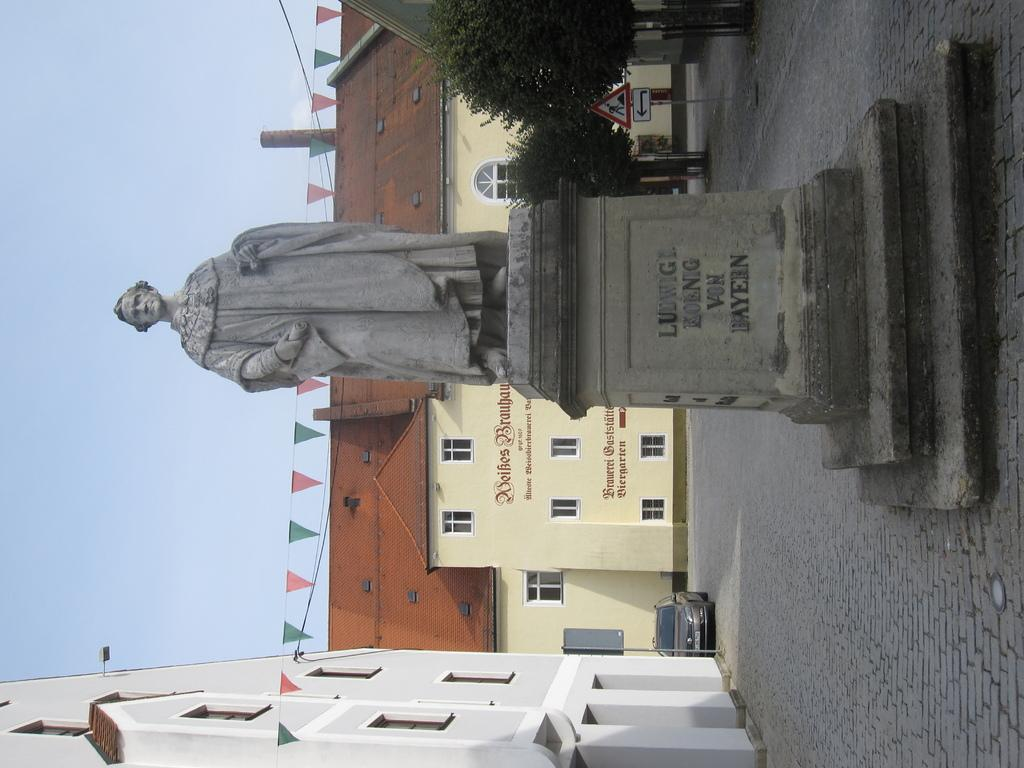<image>
Share a concise interpretation of the image provided. a man named Ludwig has a statue standing of him 